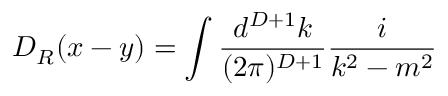<formula> <loc_0><loc_0><loc_500><loc_500>D _ { R } ( x - y ) = \int \frac { d ^ { D + 1 } k } { ( 2 \pi ) ^ { D + 1 } } \frac { i } { k ^ { 2 } - m ^ { 2 } }</formula> 